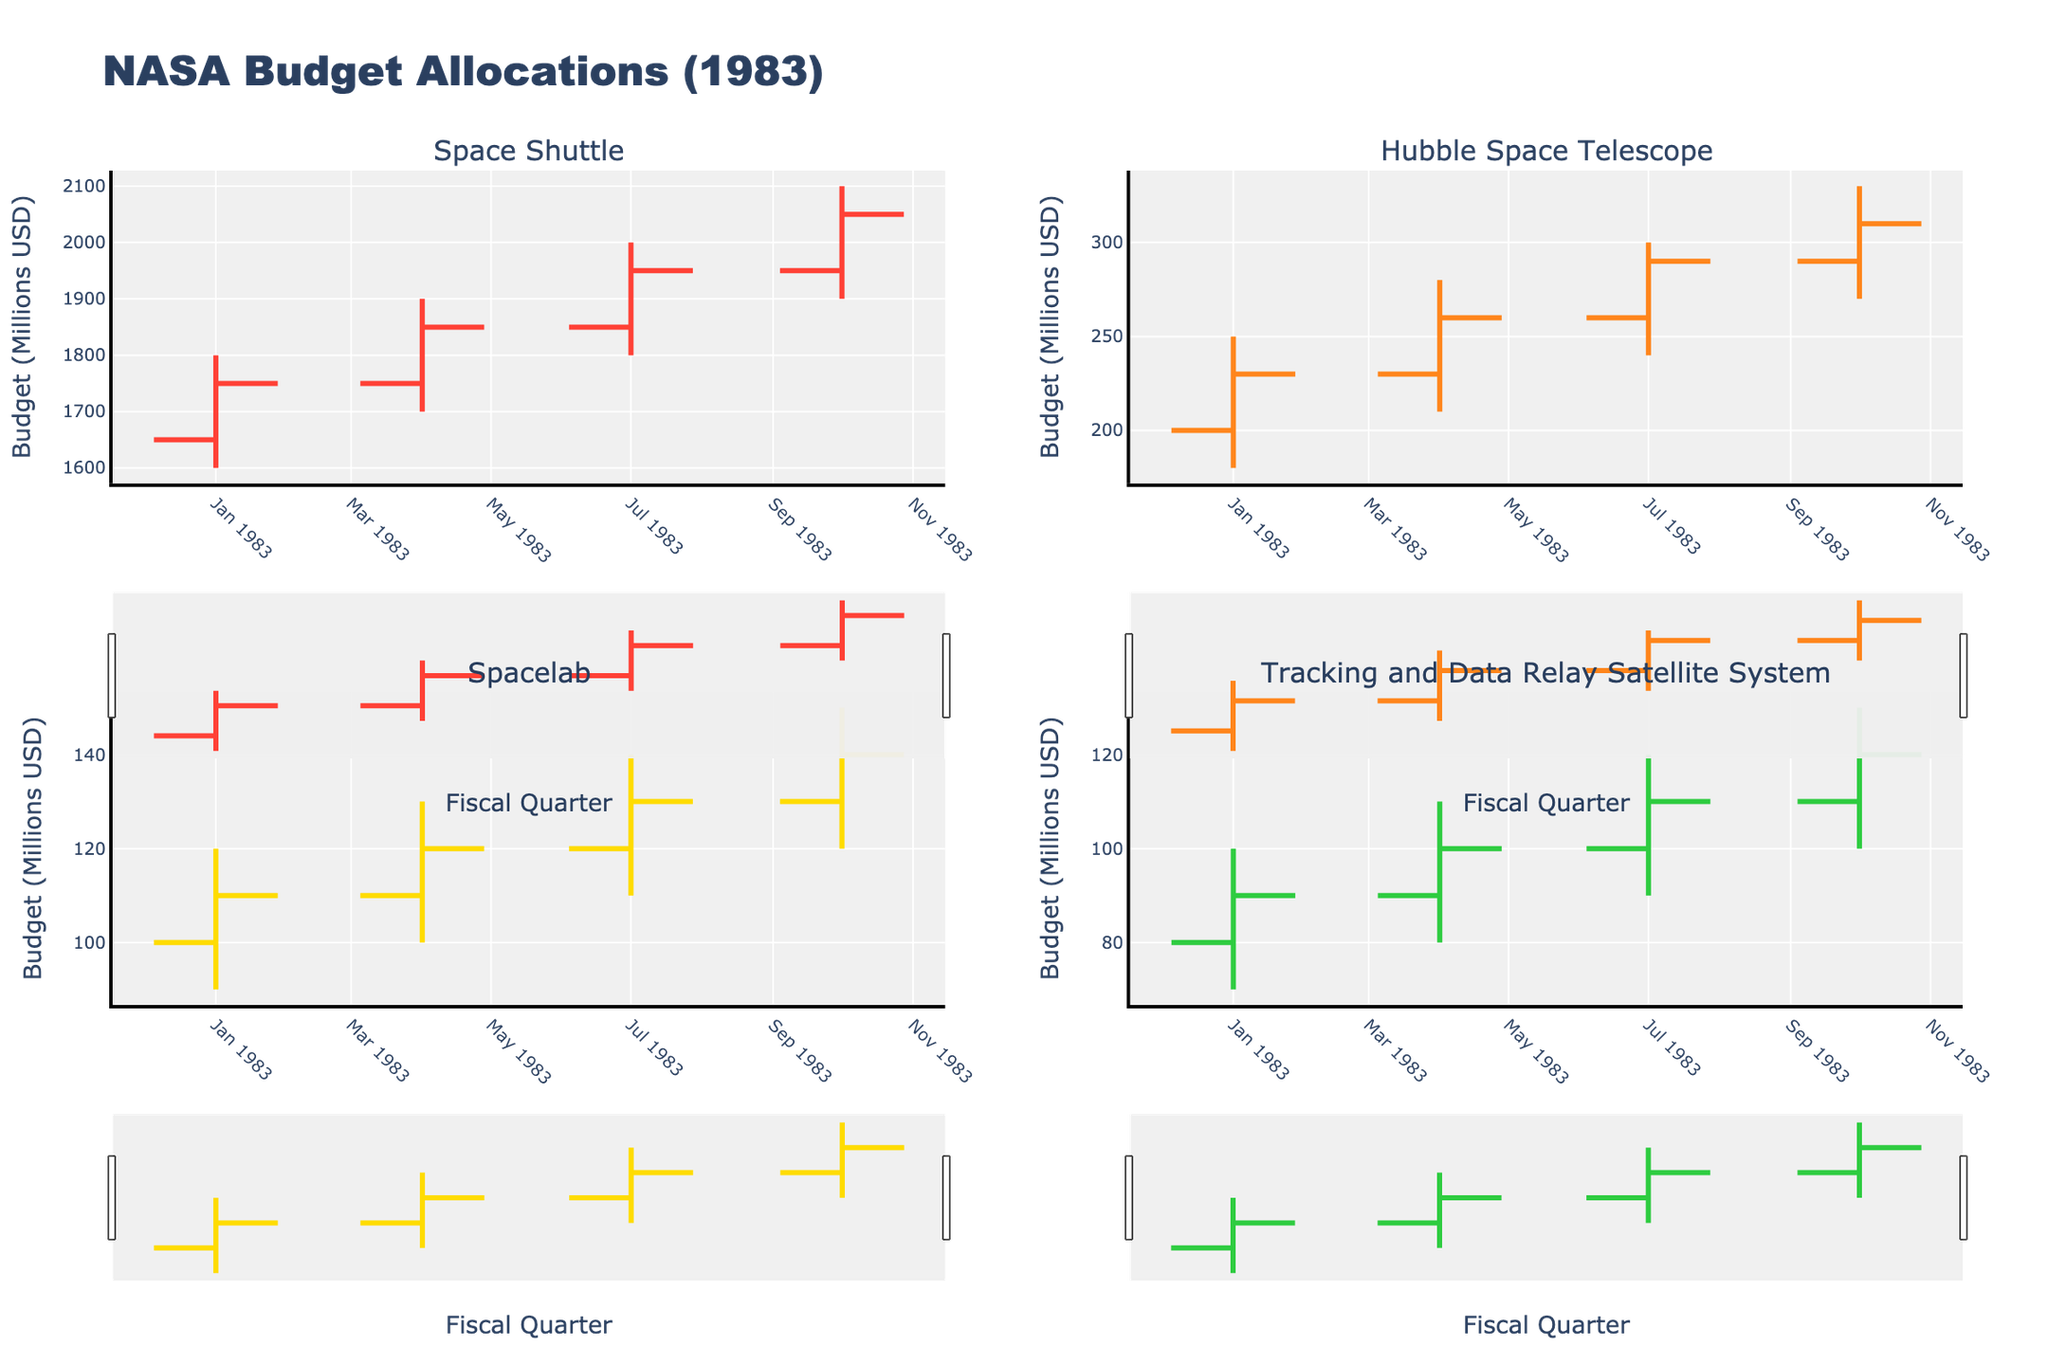What's the title of the figure? The title is usually located at the top center of the figure. Here it reads "NASA Budget Allocations (1983)".
Answer: NASA Budget Allocations (1983) How many space programs are displayed in the figure? The four subplots each represent a different program, based on the subplot titles. These programs are "Space Shuttle", "Hubble Space Telescope", "Spacelab", and "Tracking and Data Relay Satellite System".
Answer: Four Which program had the highest budget allocation in any fiscal quarter? Among the four programs, the Space Shuttle had the highest budget allocation. In 1983-Q4, its high point reached 2100 million USD.
Answer: Space Shuttle What was the budget range for the Hubble Space Telescope in 1983-Q2? The range in a quarter is the difference between the high and low budget allocations. For the Hubble Space Telescope in 1983-Q2, the high was 280 million USD and the low was 210 million USD, so the range is 280 - 210 = 70 million USD.
Answer: 70 million USD Between the Spacelab and the Tracking and Data Relay Satellite System, which program had a higher closing budget in 1983-Q3? The closing budget in the third fiscal quarter of 1983 for the Spacelab was 130 million USD, while for the Tracking and Data Relay Satellite System, it was 110 million USD. Comparing these values, Spacelab had the higher closing budget.
Answer: Spacelab How did the closing budget for the Space Shuttle change from 1983-Q1 to 1983-Q4? To calculate the change, we subtract the closing budget in 1983-Q1 from that in 1983-Q4. The closing budget in 1983-Q1 was 1750 million USD and in 1983-Q4 it was 2050 million USD. Therefore, the change is 2050 - 1750 = 300 million USD.
Answer: Increased by 300 million USD What was the average closing budget for the Tracking and Data Relay Satellite System in 1983? The closing budgets for the Tracking and Data Relay Satellite System across the quarters are 90, 100, 110, and 120 million USD. The average is calculated as (90 + 100 + 110 + 120) / 4 = 105 million USD.
Answer: 105 million USD During which fiscal quarter did the Spacelab have its lowest opening budget? By reviewing the opening budgets across the quarters, the lowest for Spacelab was in 1983-Q1 at 100 million USD.
Answer: 1983-Q1 Was the trend of the closing budget for the Hubble Space Telescope always increasing or did it have dips? Observing the four closing values (230, 260, 290, 310), we see that it increased every quarter without any dips.
Answer: Always increasing Which fiscal quarter saw the highest increase in the closing budget for the Hubble Space Telescope? To find this, we calculate the difference between consecutive closing budgets. The increases are: Q1 to Q2: 260 - 230 = 30, Q2 to Q3: 290 - 260 = 30, and Q3 to Q4: 310 - 290 = 20. The highest increase is between Q1 to Q2 and Q2 to Q3, both at 30 million USD.
Answer: 1983-Q2 or 1983-Q3 